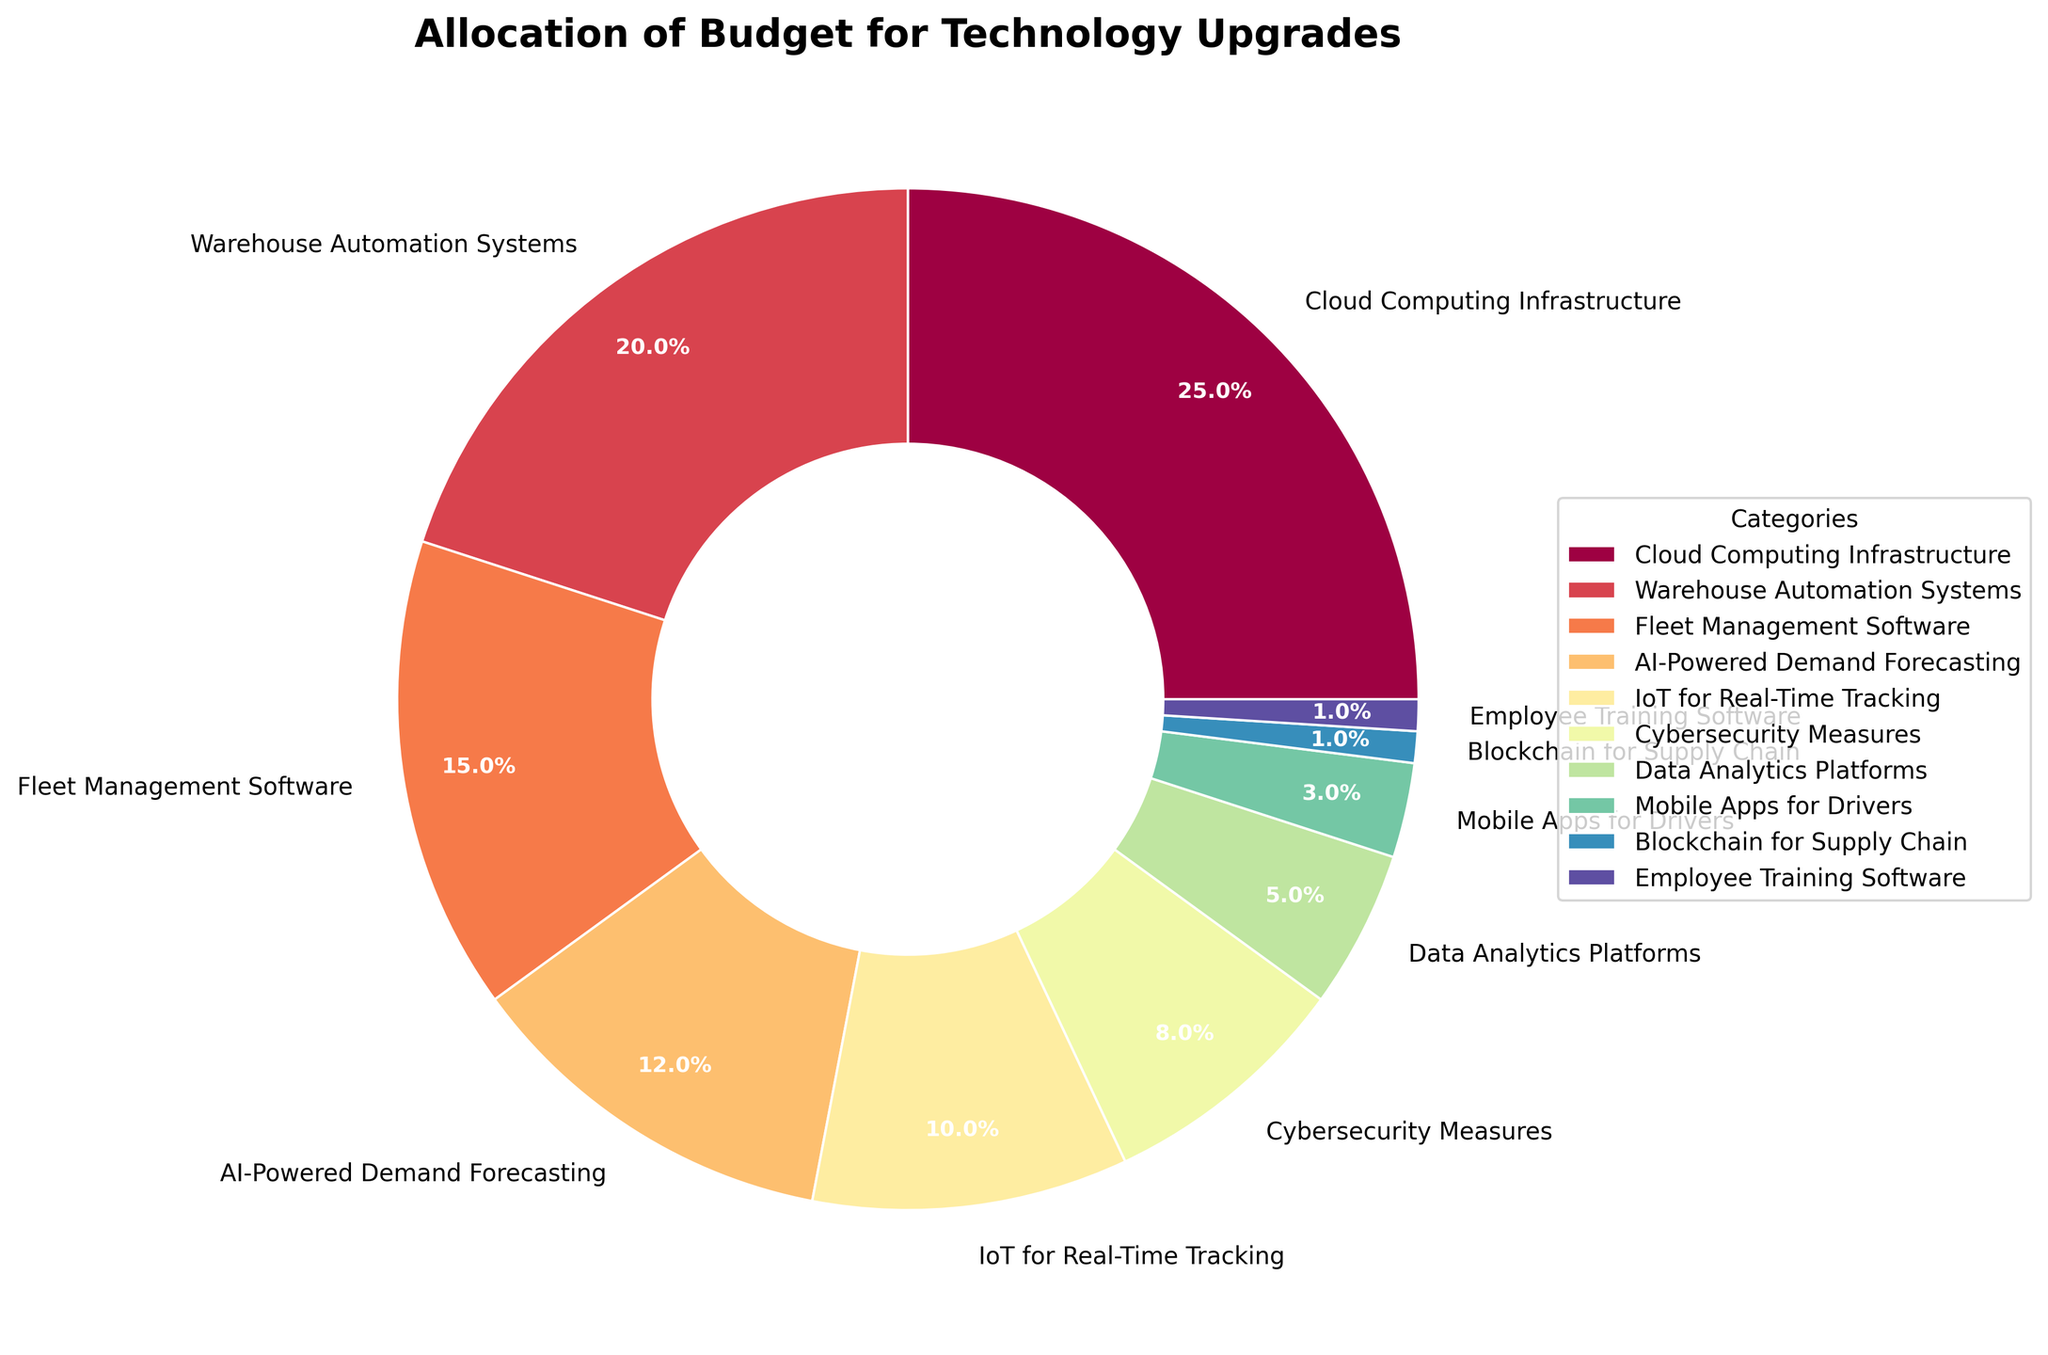what percentage of the budget is allocated to the top two categories combined? The top two categories are "Cloud Computing Infrastructure" with 25% and "Warehouse Automation Systems" with 20%. Adding these two percentages together, 25% + 20% = 45%.
Answer: 45% which category has the smallest budget allocation? The category with the smallest budget allocation is "Blockchain for Supply Chain" and "Employee Training Software," both with 1%.
Answer: Blockchain for Supply Chain and Employee Training Software how much more budget is allocated to Cloud Computing Infrastructure than to IoT for Real-Time Tracking? The budget for "Cloud Computing Infrastructure" is 25%, and for "IoT for Real-Time Tracking" it is 10%. Subtracting these, 25% - 10% = 15%.
Answer: 15% which category has a higher budget allocation: Fleet Management Software or AI-Powered Demand Forecasting? "Fleet Management Software" has a budget allocation of 15%, while "AI-Powered Demand Forecasting" has 12%. Comparing these, Fleet Management Software is higher.
Answer: Fleet Management Software what is the combined budget allocation for Cybersecurity Measures, Data Analytics Platforms, and Mobile Apps for Drivers? The budget allocations are "Cybersecurity Measures" at 8%, "Data Analytics Platforms" at 5%, and "Mobile Apps for Drivers" at 3%. Adding these together, 8% + 5% + 3% = 16%.
Answer: 16% which category does not have a double-digit percentage allocation? Categories without double-digit percentage allocations are "Cybersecurity Measures" (8%), "Data Analytics Platforms" (5%), "Mobile Apps for Drivers" (3%), "Blockchain for Supply Chain" (1%), and "Employee Training Software" (1%).
Answer: Cybersecurity Measures, Data Analytics Platforms, Mobile Apps for Drivers, Blockchain for Supply Chain, Employee Training Software is the budget allocated to AI-Powered Demand Forecasting greater than the combined budget of Mobile Apps for Drivers and Blockchain for Supply Chain? The budget for "AI-Powered Demand Forecasting" is 12%, while the combined budget for "Mobile Apps for Drivers" (3%) and "Blockchain for Supply Chain" (1%) is 3% + 1% = 4%. Comparing these, 12% is greater than 4%.
Answer: Yes 